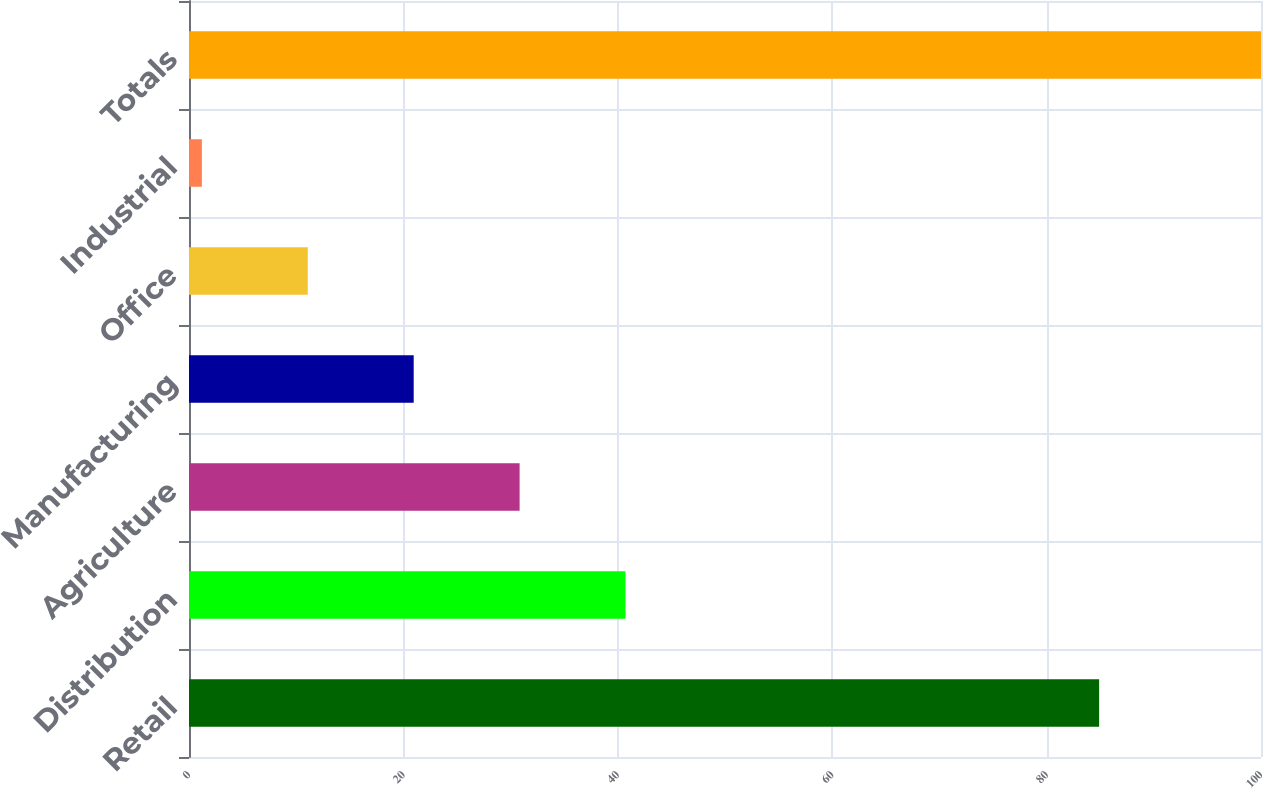<chart> <loc_0><loc_0><loc_500><loc_500><bar_chart><fcel>Retail<fcel>Distribution<fcel>Agriculture<fcel>Manufacturing<fcel>Office<fcel>Industrial<fcel>Totals<nl><fcel>84.9<fcel>40.72<fcel>30.84<fcel>20.96<fcel>11.08<fcel>1.2<fcel>100<nl></chart> 